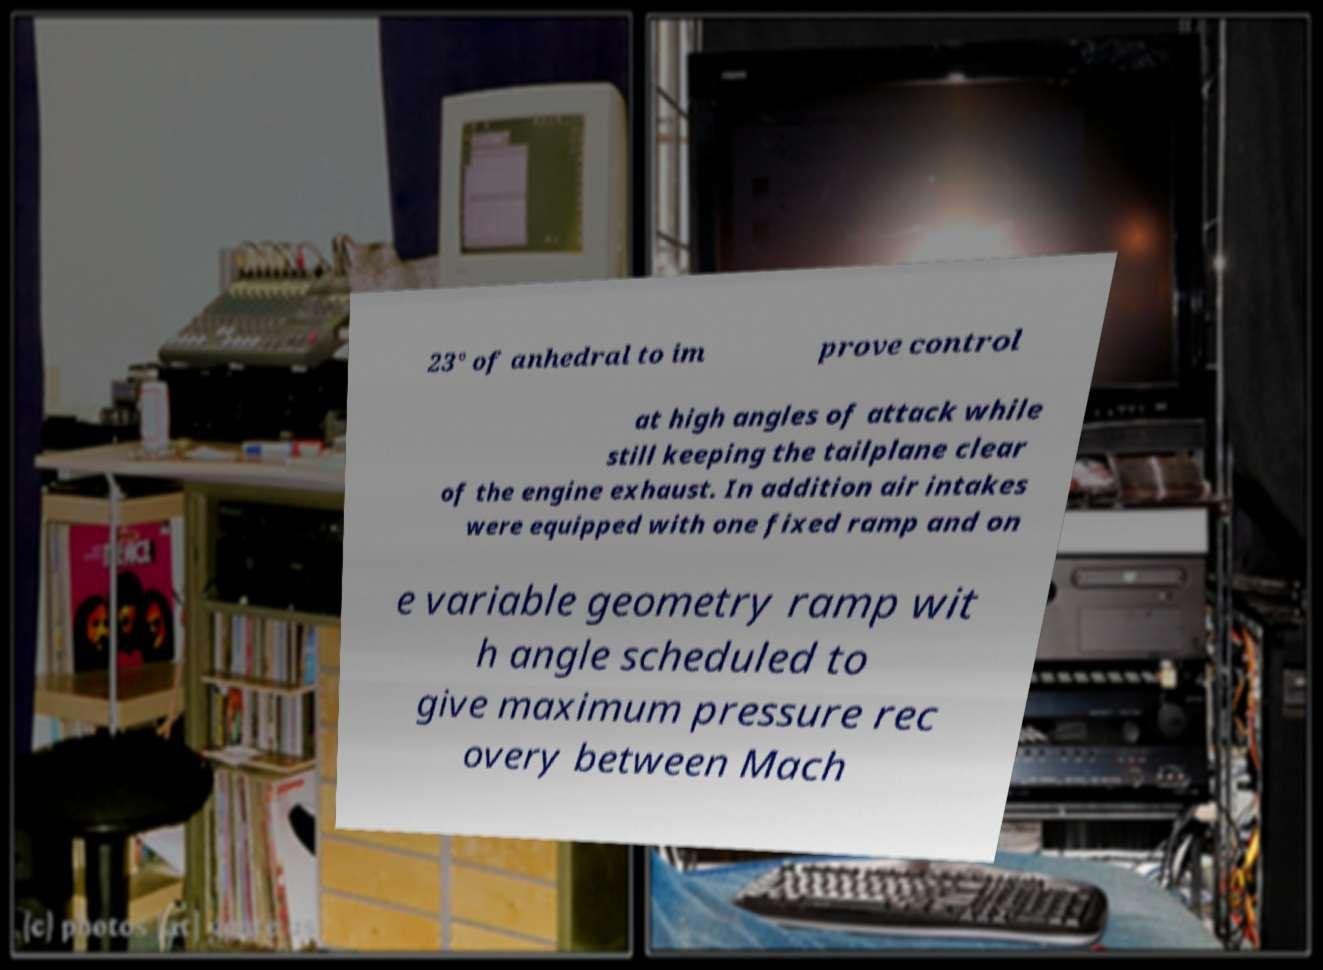Could you assist in decoding the text presented in this image and type it out clearly? 23° of anhedral to im prove control at high angles of attack while still keeping the tailplane clear of the engine exhaust. In addition air intakes were equipped with one fixed ramp and on e variable geometry ramp wit h angle scheduled to give maximum pressure rec overy between Mach 